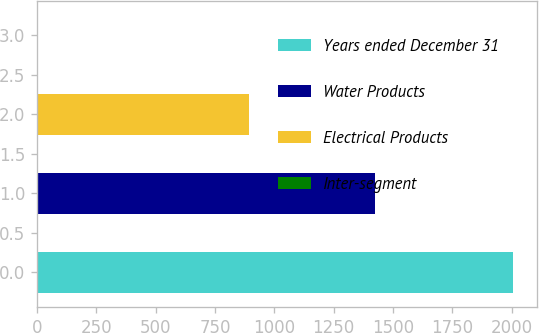Convert chart to OTSL. <chart><loc_0><loc_0><loc_500><loc_500><bar_chart><fcel>Years ended December 31<fcel>Water Products<fcel>Electrical Products<fcel>Inter-segment<nl><fcel>2007<fcel>1423.1<fcel>894<fcel>5<nl></chart> 